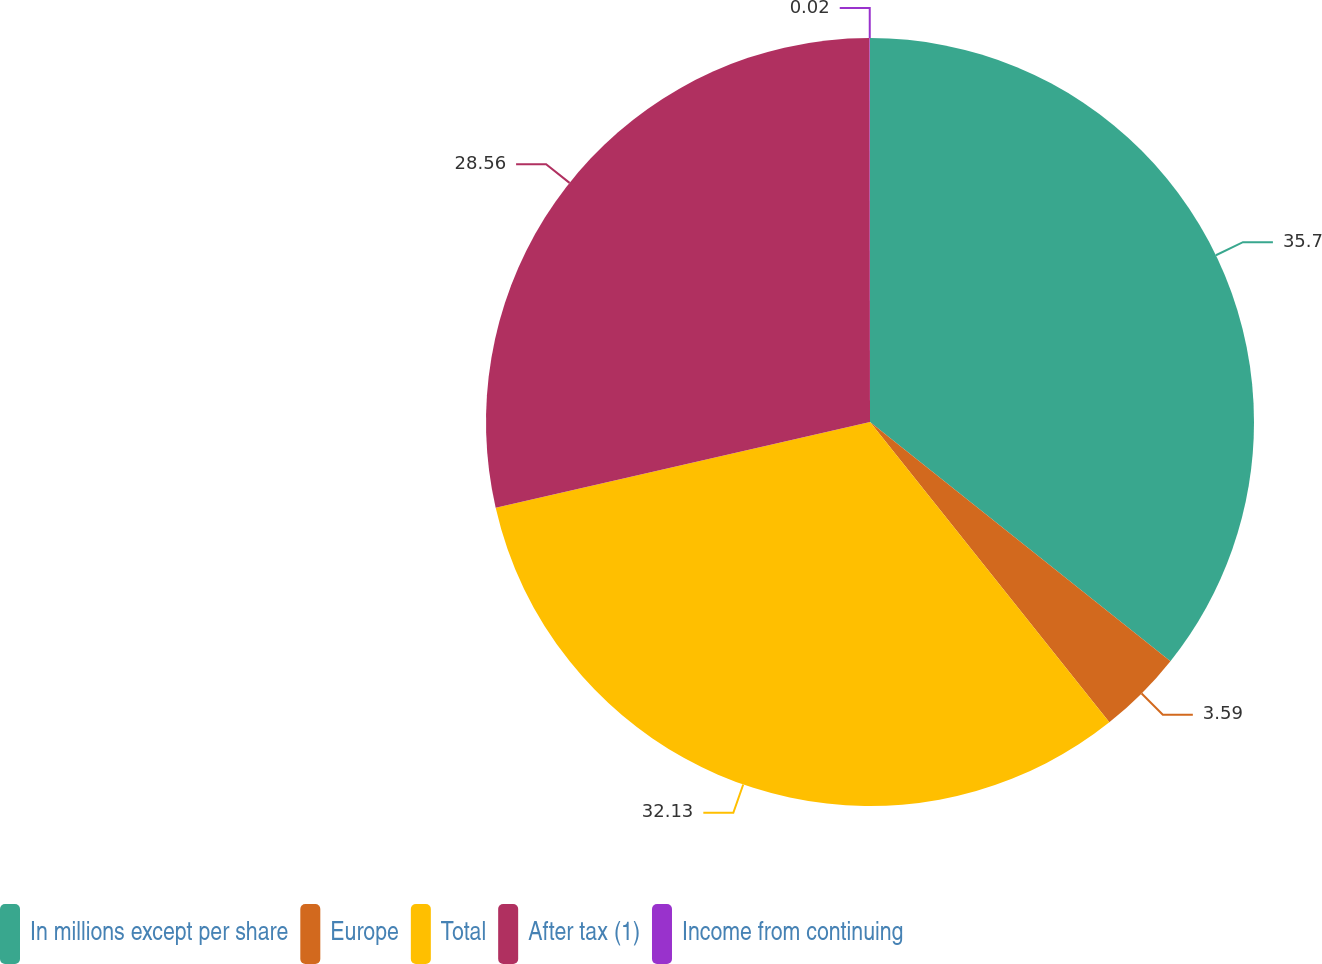Convert chart. <chart><loc_0><loc_0><loc_500><loc_500><pie_chart><fcel>In millions except per share<fcel>Europe<fcel>Total<fcel>After tax (1)<fcel>Income from continuing<nl><fcel>35.7%<fcel>3.59%<fcel>32.13%<fcel>28.56%<fcel>0.02%<nl></chart> 